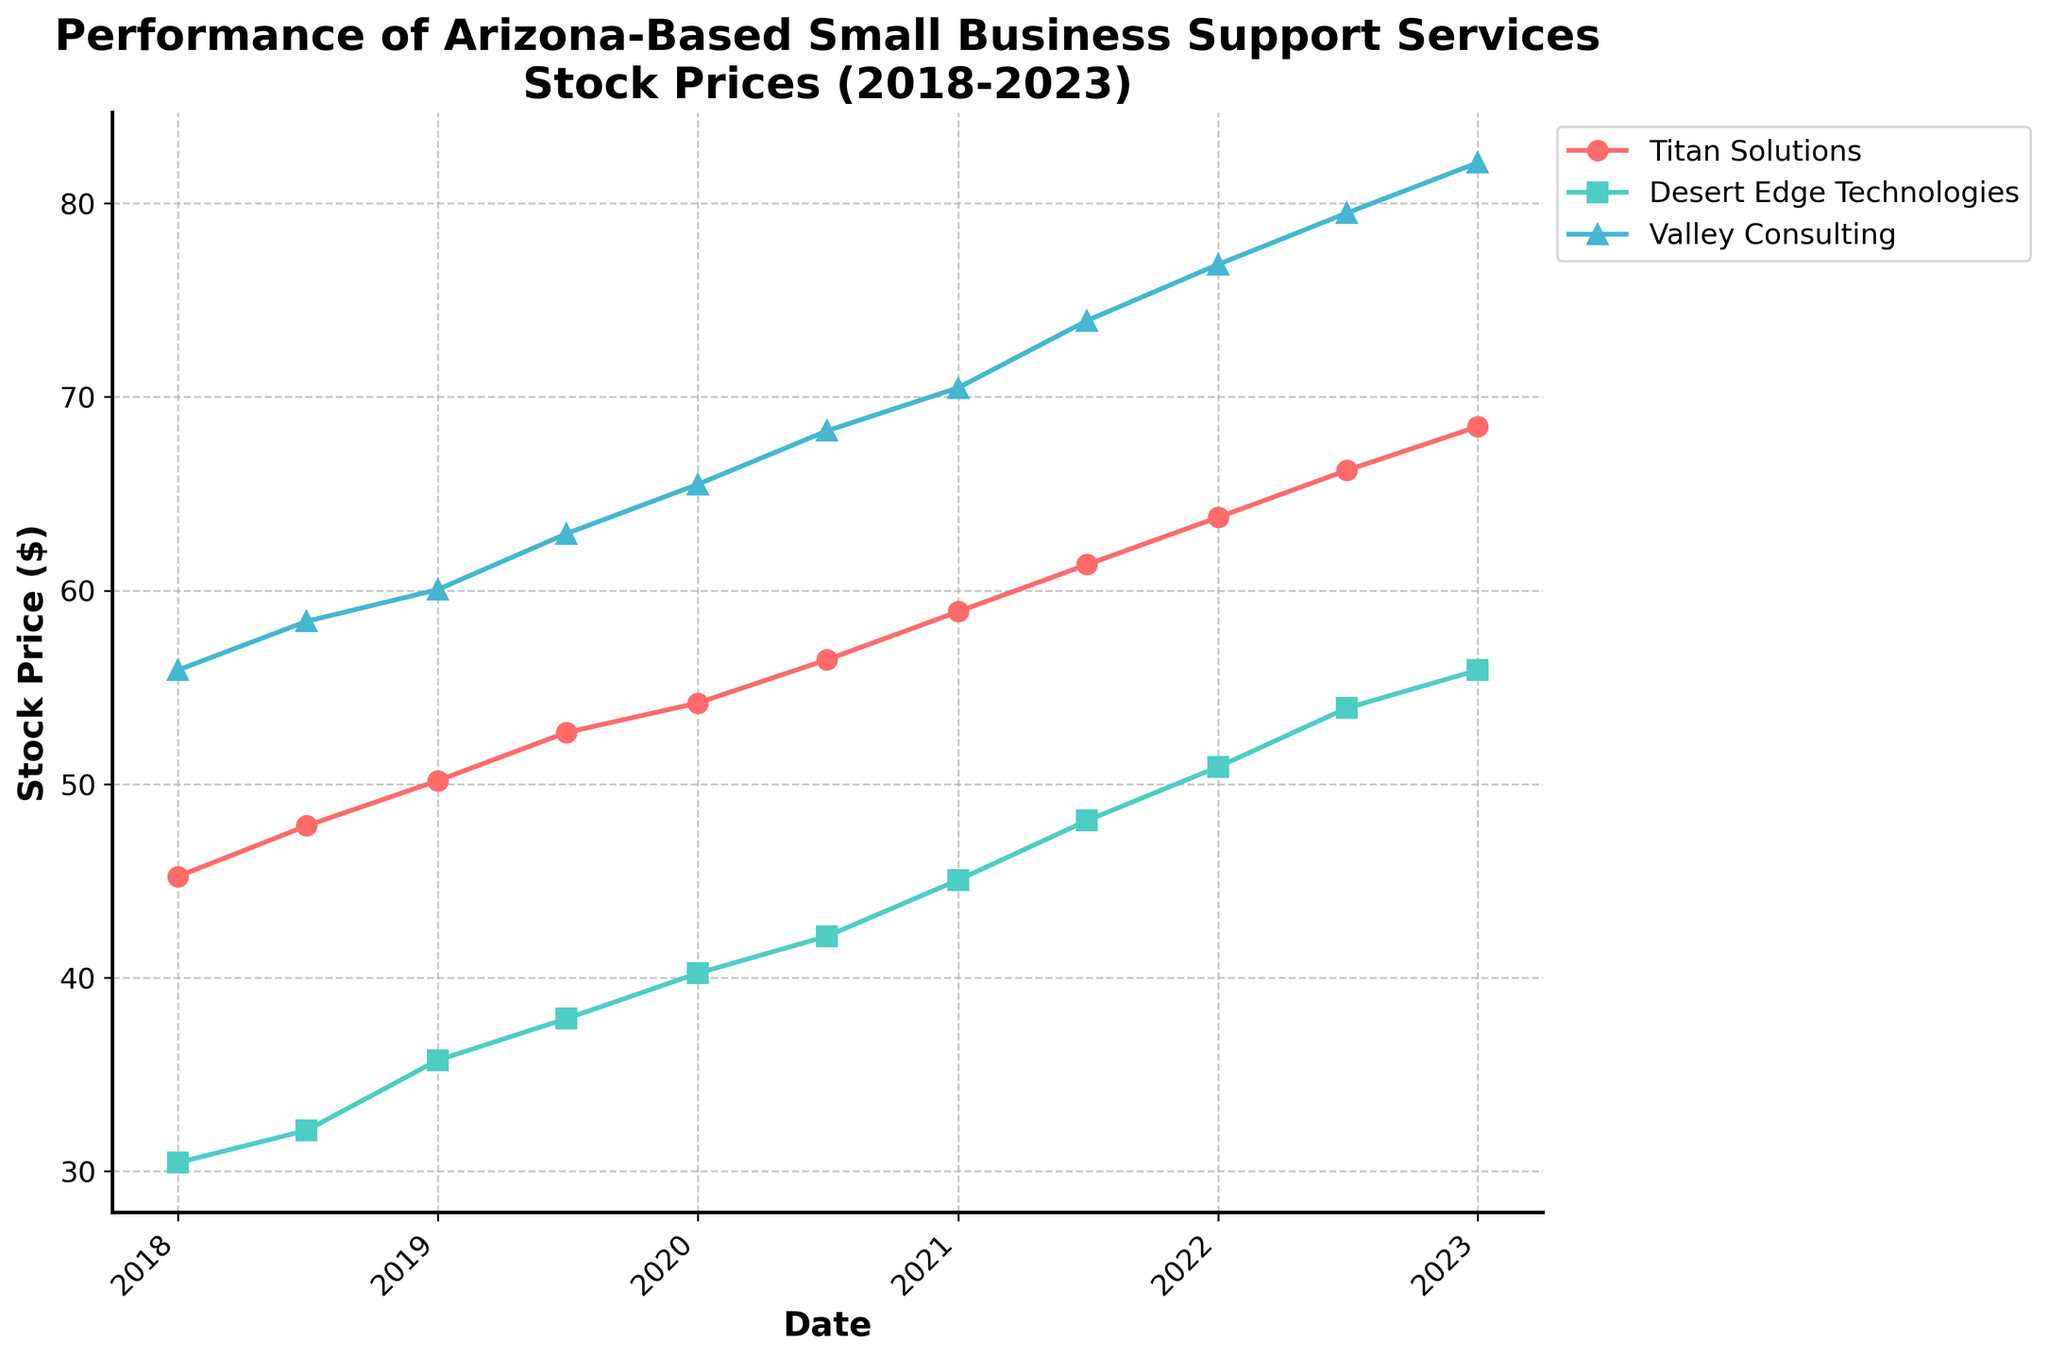What is the title of the figure? The title is located at the top of the plot and should summarize the content of the figure.
Answer: Performance of Arizona-Based Small Business Support Services Stock Prices (2018-2023) How many companies are represented in the plot? The plot legend shows the number of companies being compared.
Answer: 3 Which company had the highest stock price at the beginning of 2018? Look at the stock prices on the x-axis corresponding to the beginning of 2018 and identify the highest value.
Answer: Valley Consulting How did Titan Solutions' stock price change from 2018 to 2023? Observe the stock prices for Titan Solutions at the start of 2018 and 2023 and calculate the difference.
Answer: It increased by 23.24 Which company saw the largest increase in stock price over the entire time period? Compare the stock prices from 2018 to 2023 for each company and calculate the difference, then identify the largest increase.
Answer: Valley Consulting What is the overall trend for Desert Edge Technologies' stock price from 2018 to 2023? Examine the stock prices for Desert Edge Technologies from 2018 to 2023 to identify the general direction of change.
Answer: Upward Which company had the smallest stock price increase from 2018 to 2023? Calculate the price change for each company from 2018 to 2023 and determine the smallest change.
Answer: Desert Edge Technologies What are the major ticks on the x-axis, and what do they represent? Look at the x-axis and identify the intervals and labels used for the major ticks.
Answer: Yearly intervals (2018, 2019, 2020, 2021, 2022, 2023) Did any company's stock price exceed $80 during the given time period? Check the y-axis values of the stock prices for any point exceeding $80.
Answer: Yes, Valley Consulting How does Valley Consulting's stock price at the end of 2021 compare to its stock price at the beginning of 2021? Look at Valley Consulting's stock prices for January and December 2021 and compare the values.
Answer: It increased by 3.47 